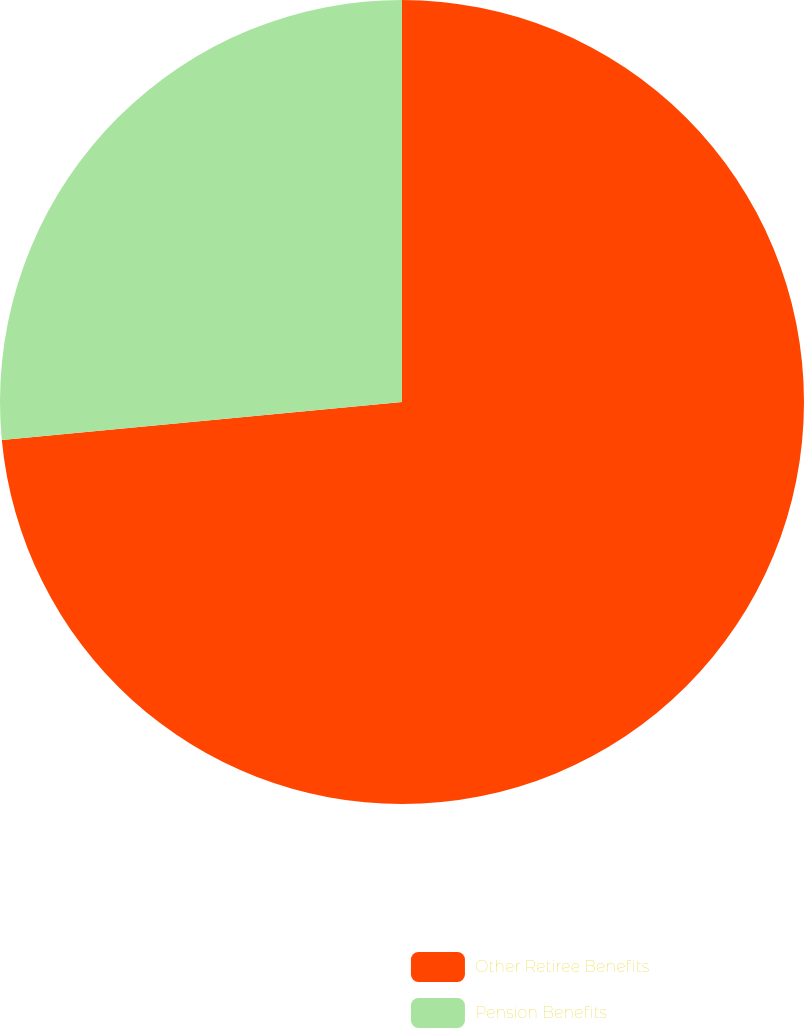Convert chart. <chart><loc_0><loc_0><loc_500><loc_500><pie_chart><fcel>Other Retiree Benefits<fcel>Pension Benefits<nl><fcel>73.49%<fcel>26.51%<nl></chart> 